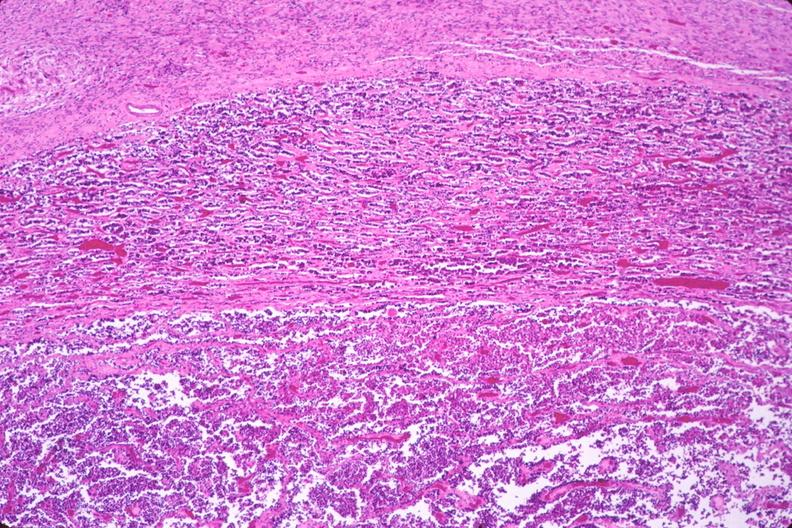what is present?
Answer the question using a single word or phrase. Endocrine 